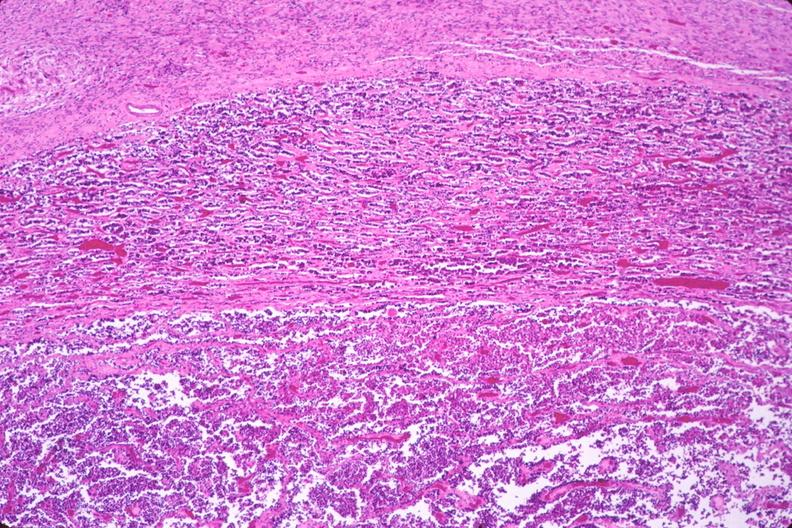what is present?
Answer the question using a single word or phrase. Endocrine 